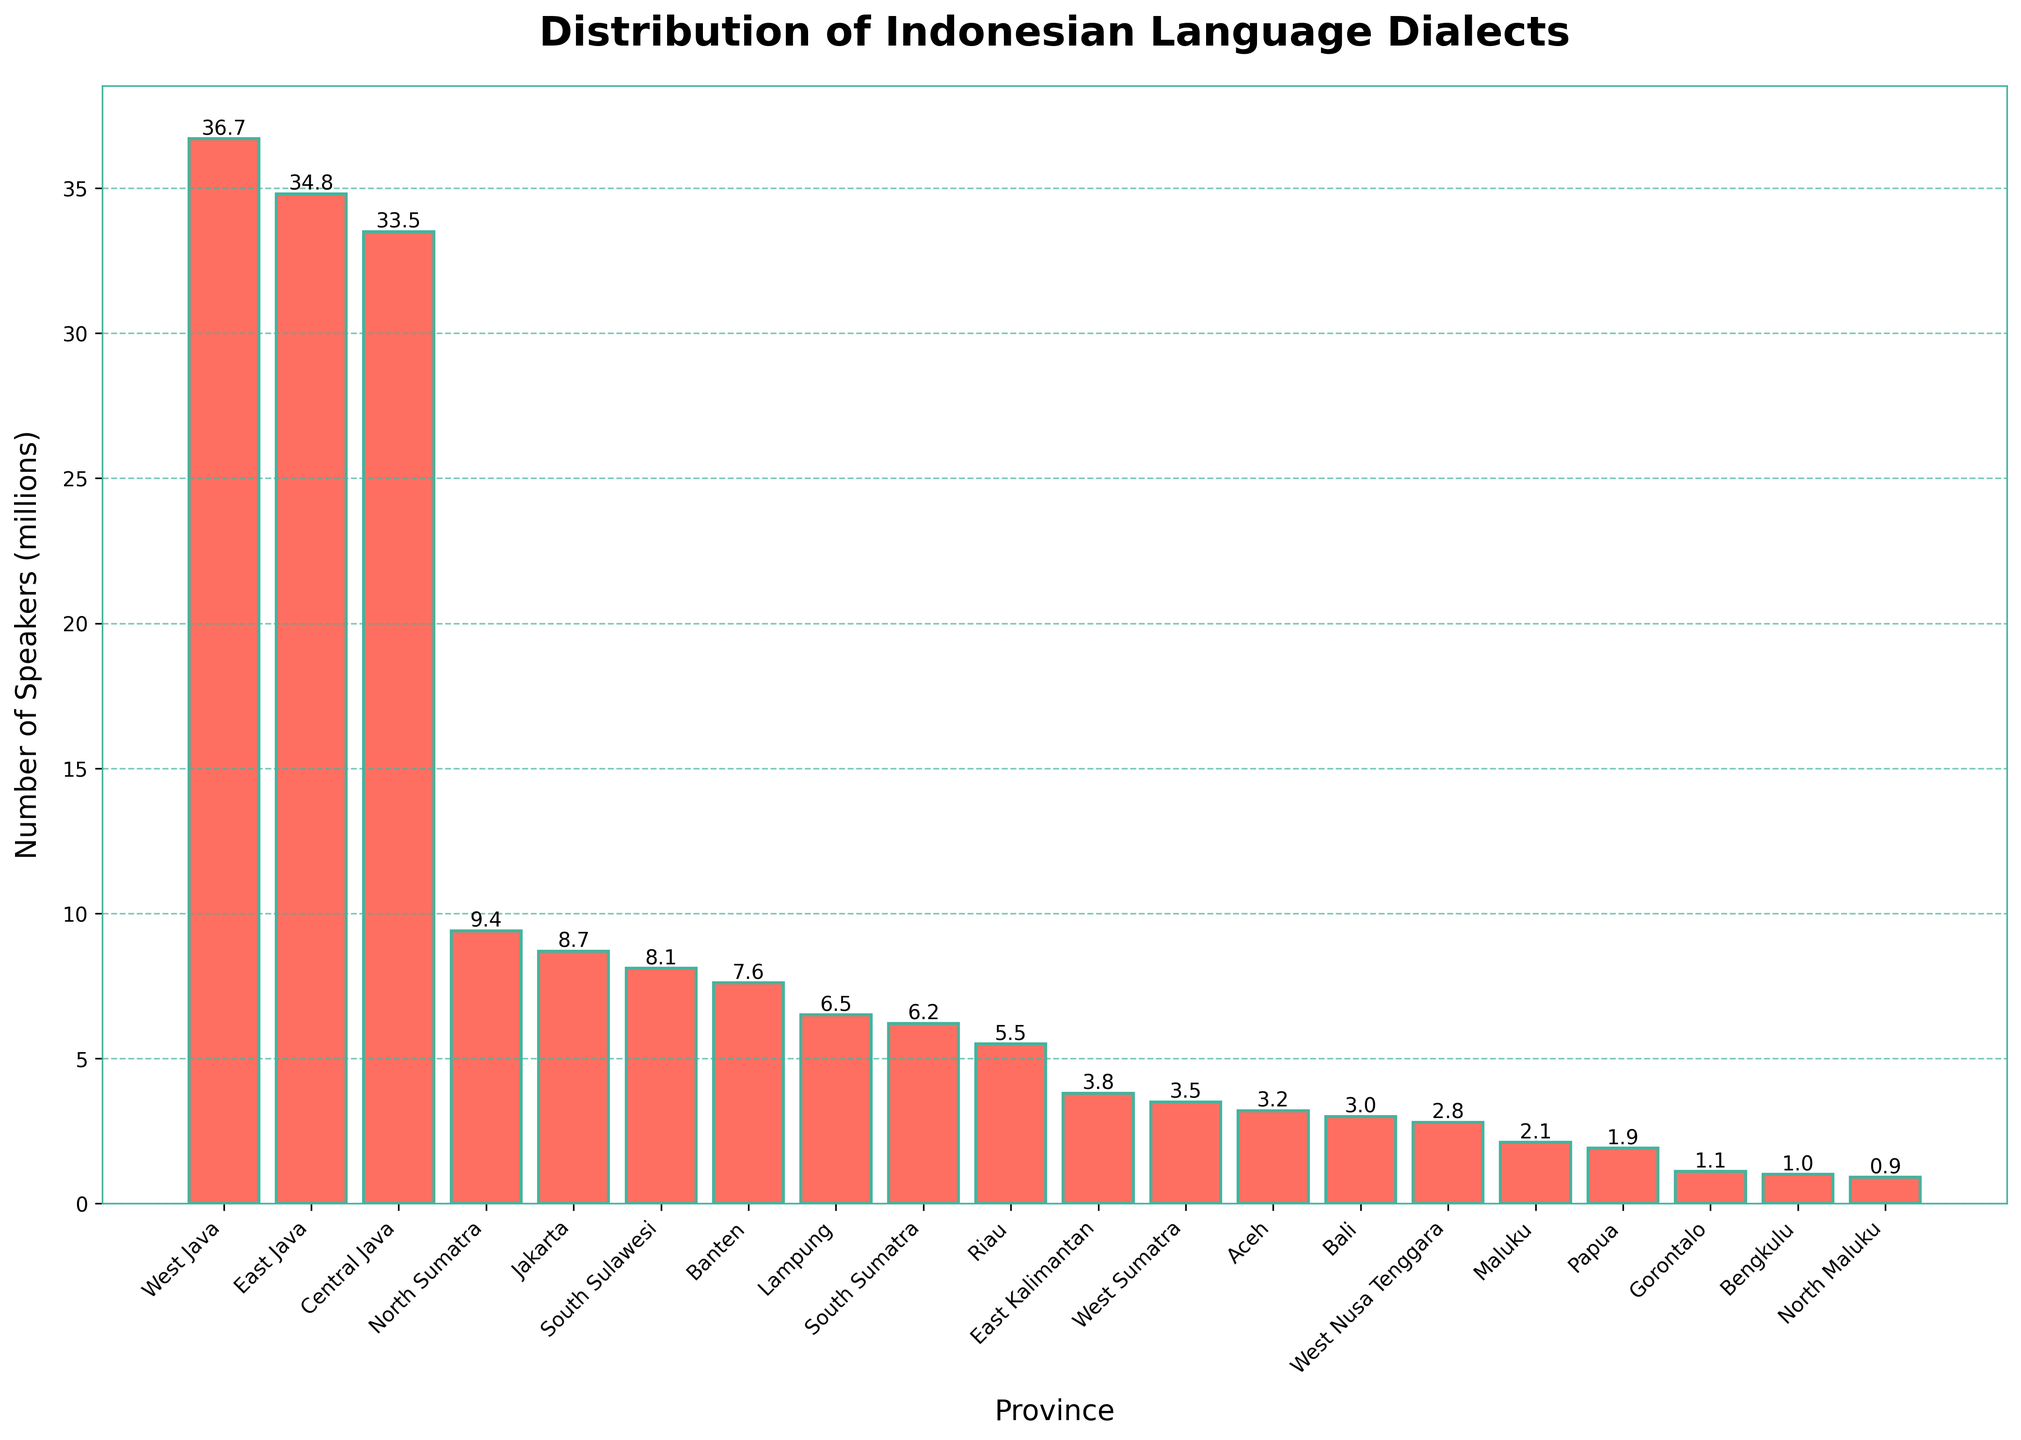what's the province with the largest number of speakers? Look for the bar with the highest value. In the chart, West Java has the highest bar, indicating the largest number of speakers.
Answer: West Java which province has more speakers, North Sumatra or South Sulawesi? Compare the bar heights for North Sumatra and South Sulawesi. North Sumatra has a higher bar (9.4 million) than South Sulawesi (8.1 million).
Answer: North Sumatra what's the difference in the number of speakers between Central Java and Jakarta? Find the heights of the bars for Central Java and Jakarta. The difference is calculated as 33.5 million (Central Java) - 8.7 million (Jakarta).
Answer: 24.8 million what is the sum of the number of speakers for the top three provinces? Identify the top three provinces (West Java, East Java, and Central Java) and sum their values: 36.7 + 34.8 + 33.5
Answer: 105 million which provinces have fewer than 3 million speakers? Look for bars with heights less than 3 million: Maluku, Papua, Gorontalo, Bengkulu, and North Maluku.
Answer: Maluku, Papua, Gorontalo, Bengkulu, and North Maluku how many provinces have between 5 and 10 million speakers? Count the bars that fall within this range: North Sumatra, Jakarta, South Sulawesi, Banten, Lampung, South Sumatra, Riau.
Answer: 7 which province has the smallest number of speakers? Identify the shortest bar in the chart. North Maluku has the smallest number of speakers.
Answer: North Maluku what's the average number of speakers for West Java, East Java, and Central Java? Sum the number of speakers for these three provinces and divide by 3: (36.7 + 34.8 + 33.5) / 3
Answer: 35 million are there more speakers in Bali or Aceh? Compare the heights of the bars for Bali and Aceh. Bali (3.0 million) has slightly fewer speakers than Aceh (3.2 million).
Answer: Aceh 